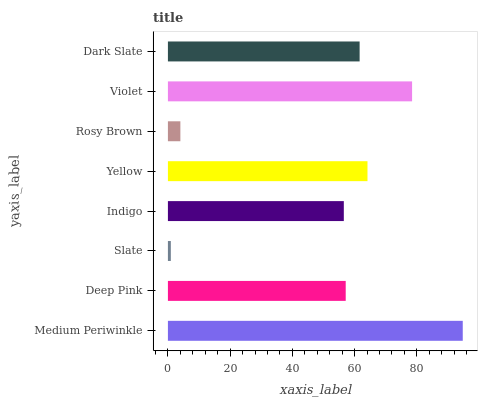Is Slate the minimum?
Answer yes or no. Yes. Is Medium Periwinkle the maximum?
Answer yes or no. Yes. Is Deep Pink the minimum?
Answer yes or no. No. Is Deep Pink the maximum?
Answer yes or no. No. Is Medium Periwinkle greater than Deep Pink?
Answer yes or no. Yes. Is Deep Pink less than Medium Periwinkle?
Answer yes or no. Yes. Is Deep Pink greater than Medium Periwinkle?
Answer yes or no. No. Is Medium Periwinkle less than Deep Pink?
Answer yes or no. No. Is Dark Slate the high median?
Answer yes or no. Yes. Is Deep Pink the low median?
Answer yes or no. Yes. Is Deep Pink the high median?
Answer yes or no. No. Is Indigo the low median?
Answer yes or no. No. 